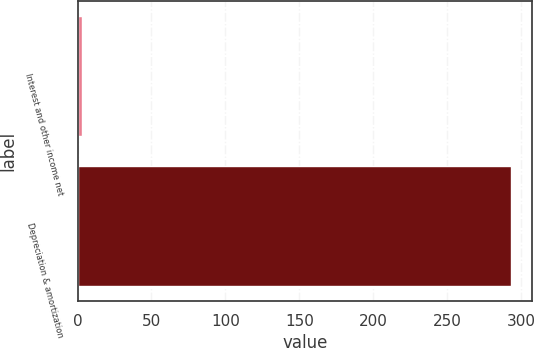Convert chart to OTSL. <chart><loc_0><loc_0><loc_500><loc_500><bar_chart><fcel>Interest and other income net<fcel>Depreciation & amortization<nl><fcel>3<fcel>293<nl></chart> 